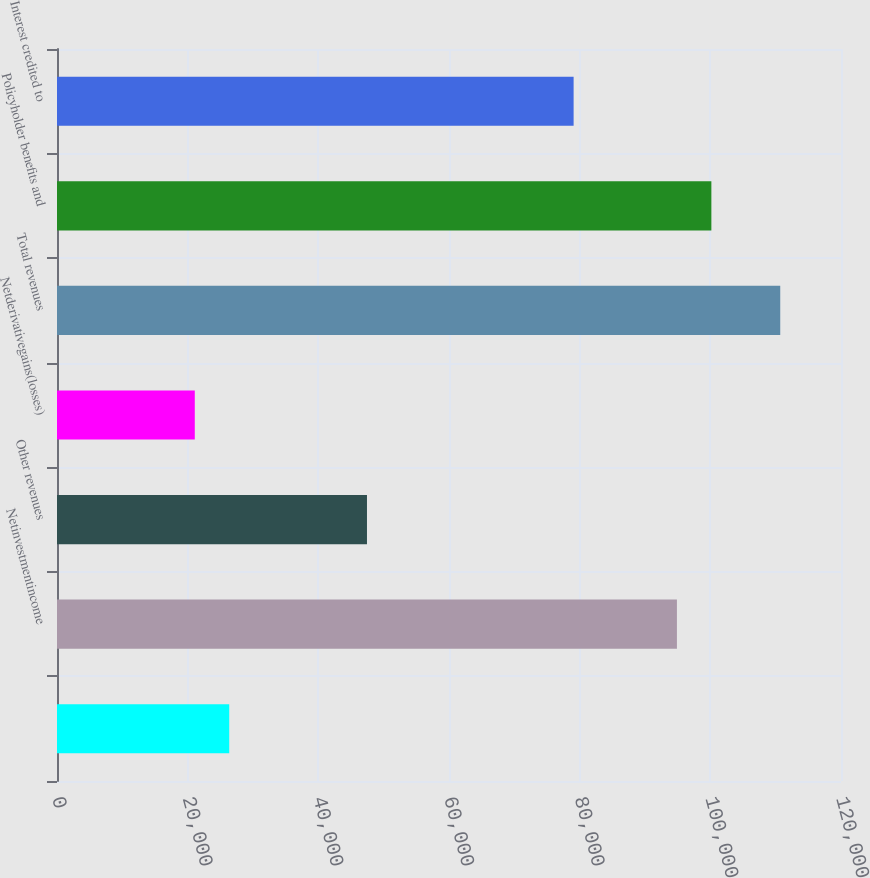<chart> <loc_0><loc_0><loc_500><loc_500><bar_chart><ecel><fcel>Netinvestmentincome<fcel>Other revenues<fcel>Netderivativegains(losses)<fcel>Total revenues<fcel>Policyholder benefits and<fcel>Interest credited to<nl><fcel>26360.5<fcel>94887.4<fcel>47445.7<fcel>21089.2<fcel>110701<fcel>100159<fcel>79073.5<nl></chart> 